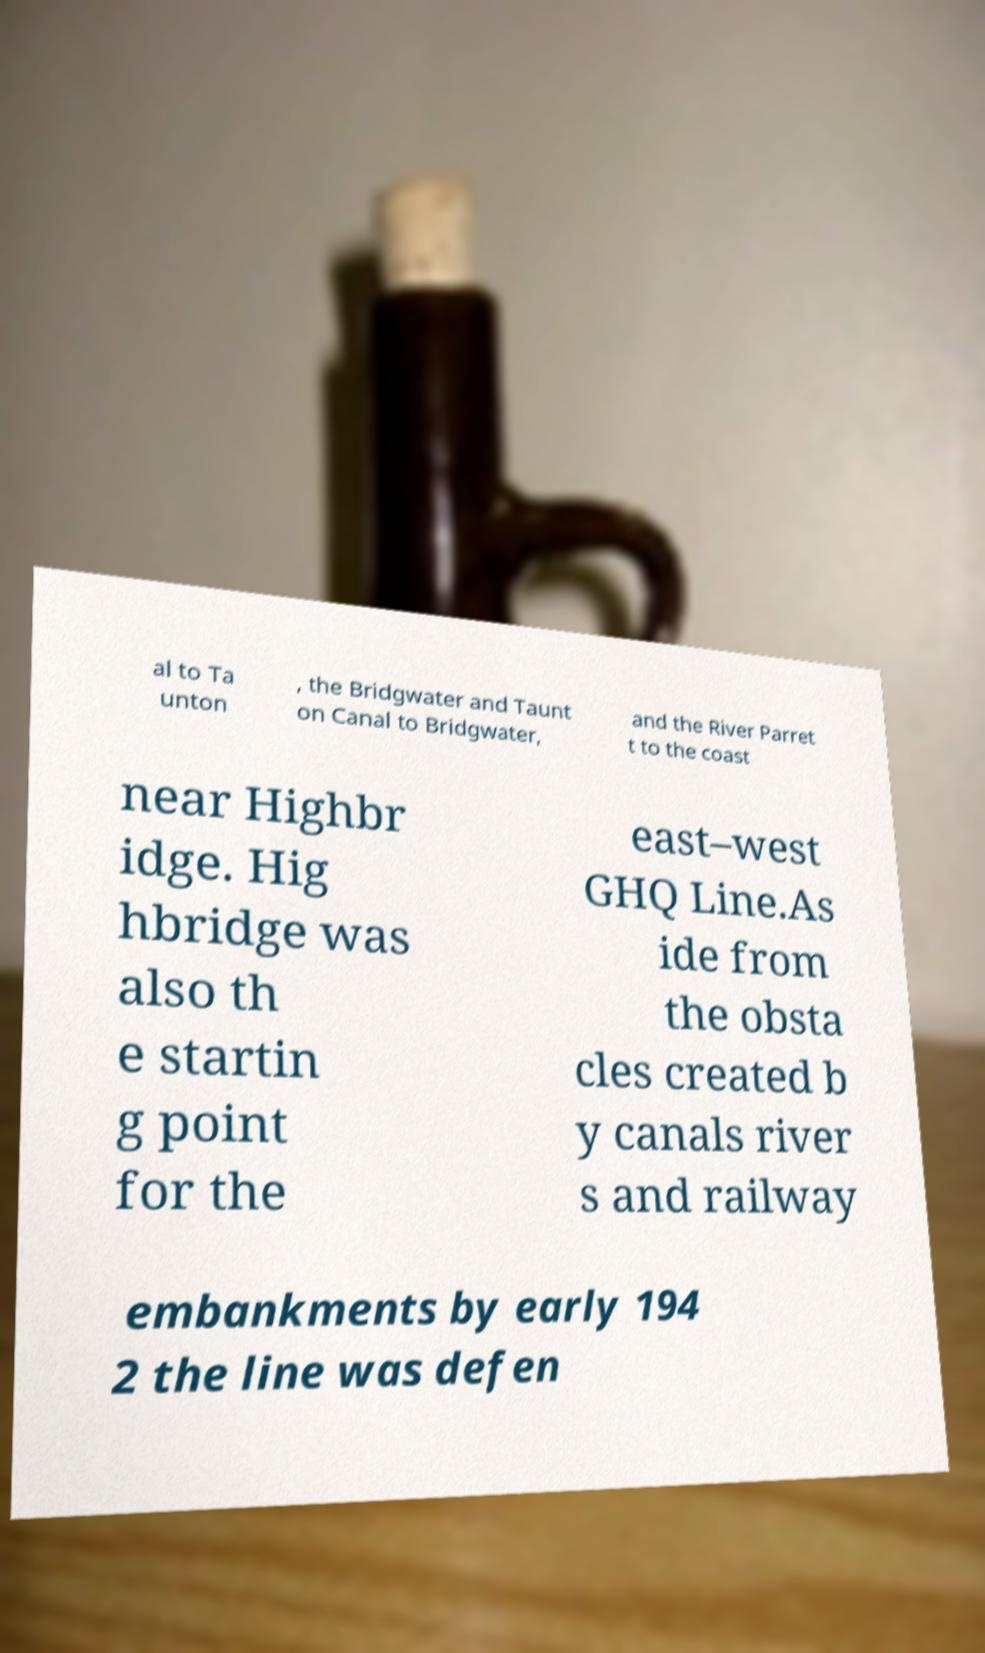For documentation purposes, I need the text within this image transcribed. Could you provide that? al to Ta unton , the Bridgwater and Taunt on Canal to Bridgwater, and the River Parret t to the coast near Highbr idge. Hig hbridge was also th e startin g point for the east–west GHQ Line.As ide from the obsta cles created b y canals river s and railway embankments by early 194 2 the line was defen 